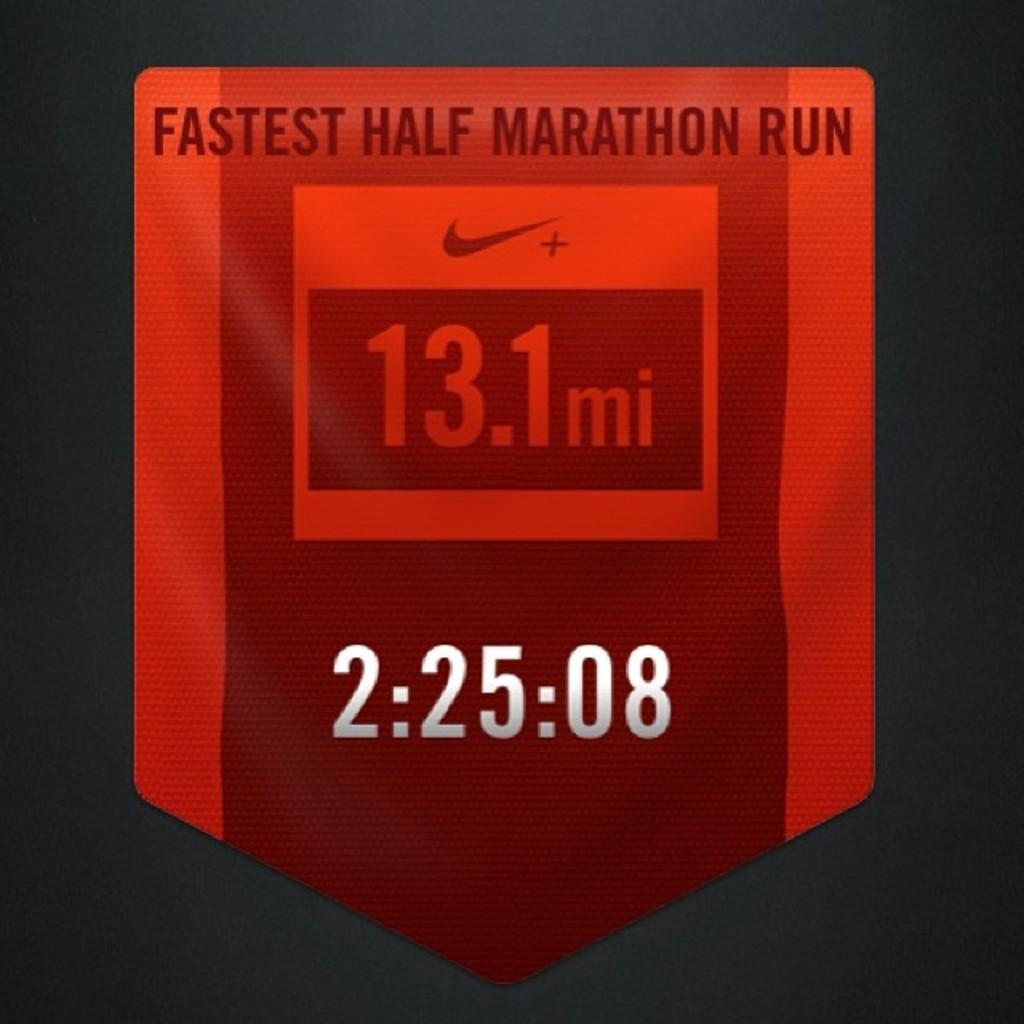<image>
Present a compact description of the photo's key features. A red banner displaying the 2:25:08 time ran in a half marathon. 